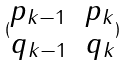<formula> <loc_0><loc_0><loc_500><loc_500>( \begin{matrix} p _ { k - 1 } & p _ { k } \\ q _ { k - 1 } & q _ { k } \end{matrix} )</formula> 